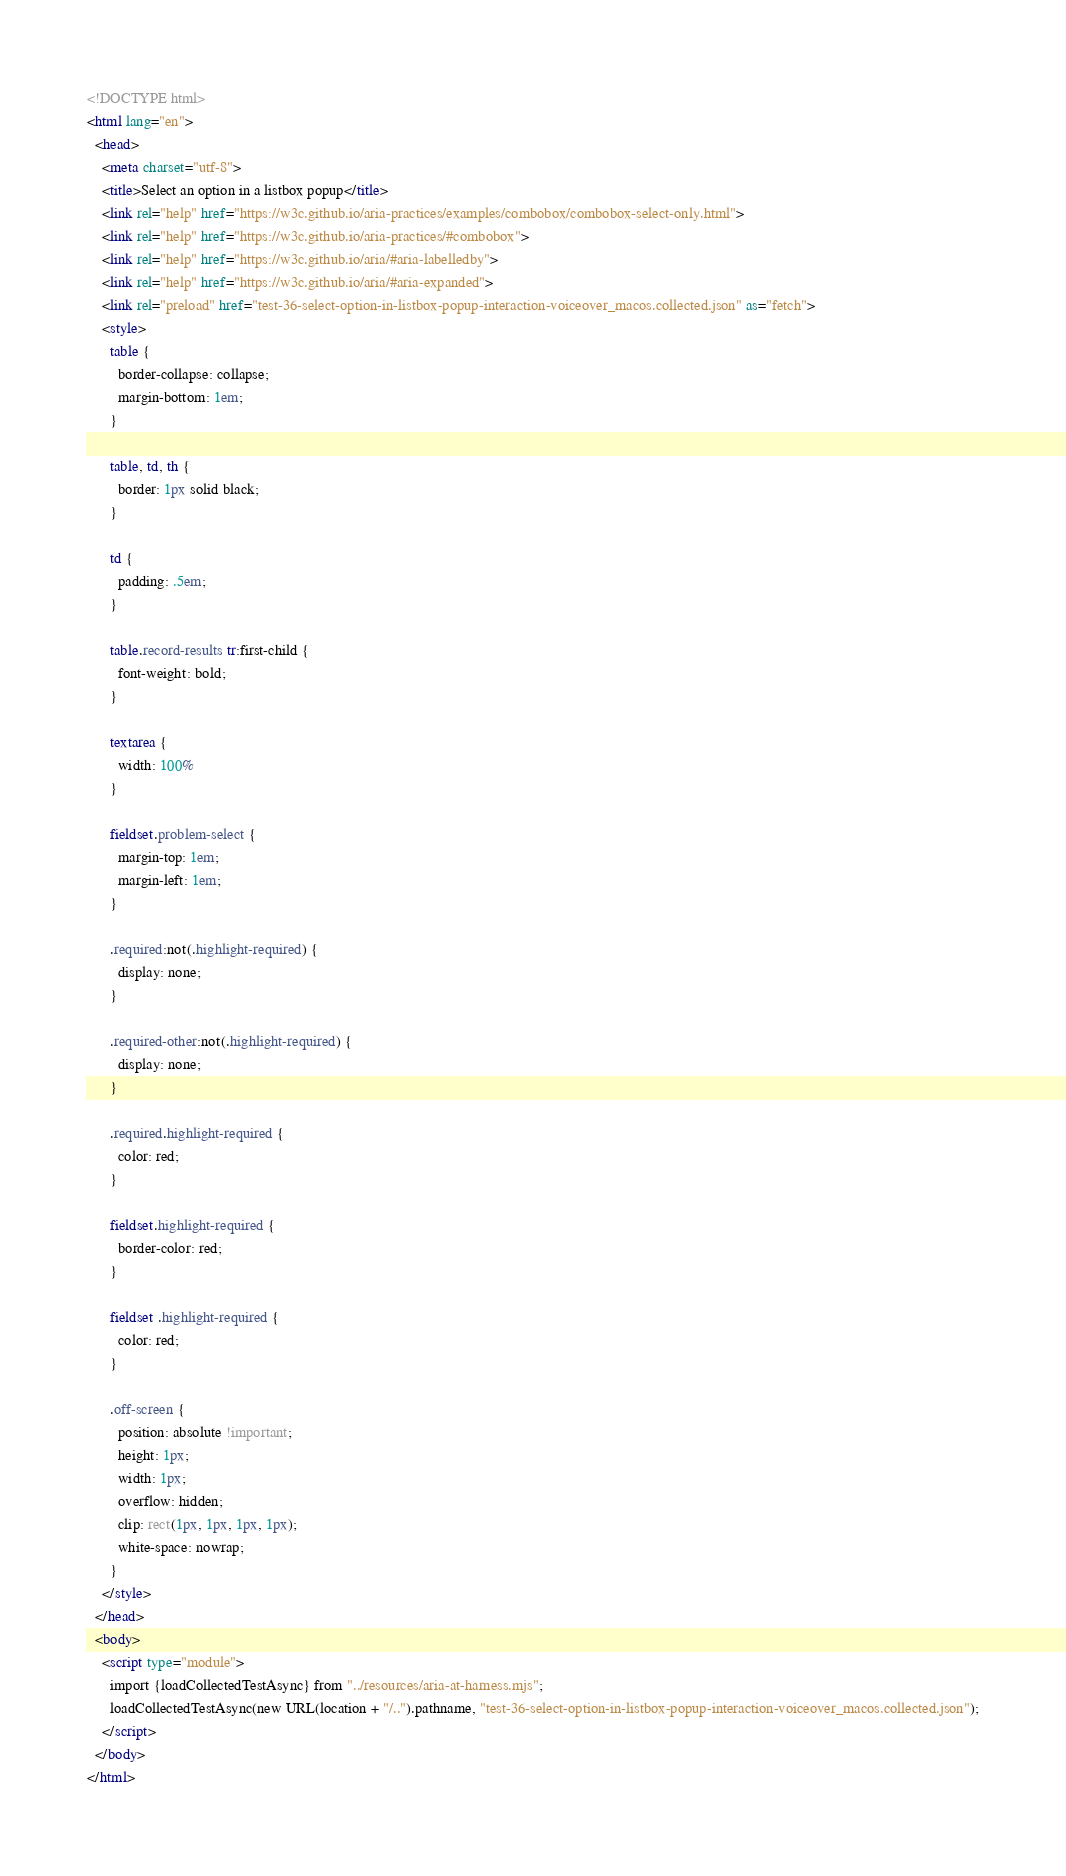<code> <loc_0><loc_0><loc_500><loc_500><_HTML_><!DOCTYPE html>
<html lang="en">
  <head>
    <meta charset="utf-8">
    <title>Select an option in a listbox popup</title>
    <link rel="help" href="https://w3c.github.io/aria-practices/examples/combobox/combobox-select-only.html">
    <link rel="help" href="https://w3c.github.io/aria-practices/#combobox">
    <link rel="help" href="https://w3c.github.io/aria/#aria-labelledby">
    <link rel="help" href="https://w3c.github.io/aria/#aria-expanded">
    <link rel="preload" href="test-36-select-option-in-listbox-popup-interaction-voiceover_macos.collected.json" as="fetch">
    <style>
      table {
        border-collapse: collapse;
        margin-bottom: 1em;
      }

      table, td, th {
        border: 1px solid black;
      }

      td {
        padding: .5em;
      }

      table.record-results tr:first-child {
        font-weight: bold;
      }

      textarea {
        width: 100%
      }

      fieldset.problem-select {
        margin-top: 1em;
        margin-left: 1em;
      }

      .required:not(.highlight-required) {
        display: none;
      }

      .required-other:not(.highlight-required) {
        display: none;
      }

      .required.highlight-required {
        color: red;
      }

      fieldset.highlight-required {
        border-color: red;
      }

      fieldset .highlight-required {
        color: red;
      }

      .off-screen {
        position: absolute !important;
        height: 1px;
        width: 1px;
        overflow: hidden;
        clip: rect(1px, 1px, 1px, 1px);
        white-space: nowrap;
      }
    </style>
  </head>
  <body>
    <script type="module">
      import {loadCollectedTestAsync} from "../resources/aria-at-harness.mjs";
      loadCollectedTestAsync(new URL(location + "/..").pathname, "test-36-select-option-in-listbox-popup-interaction-voiceover_macos.collected.json");
    </script>
  </body>
</html>
</code> 